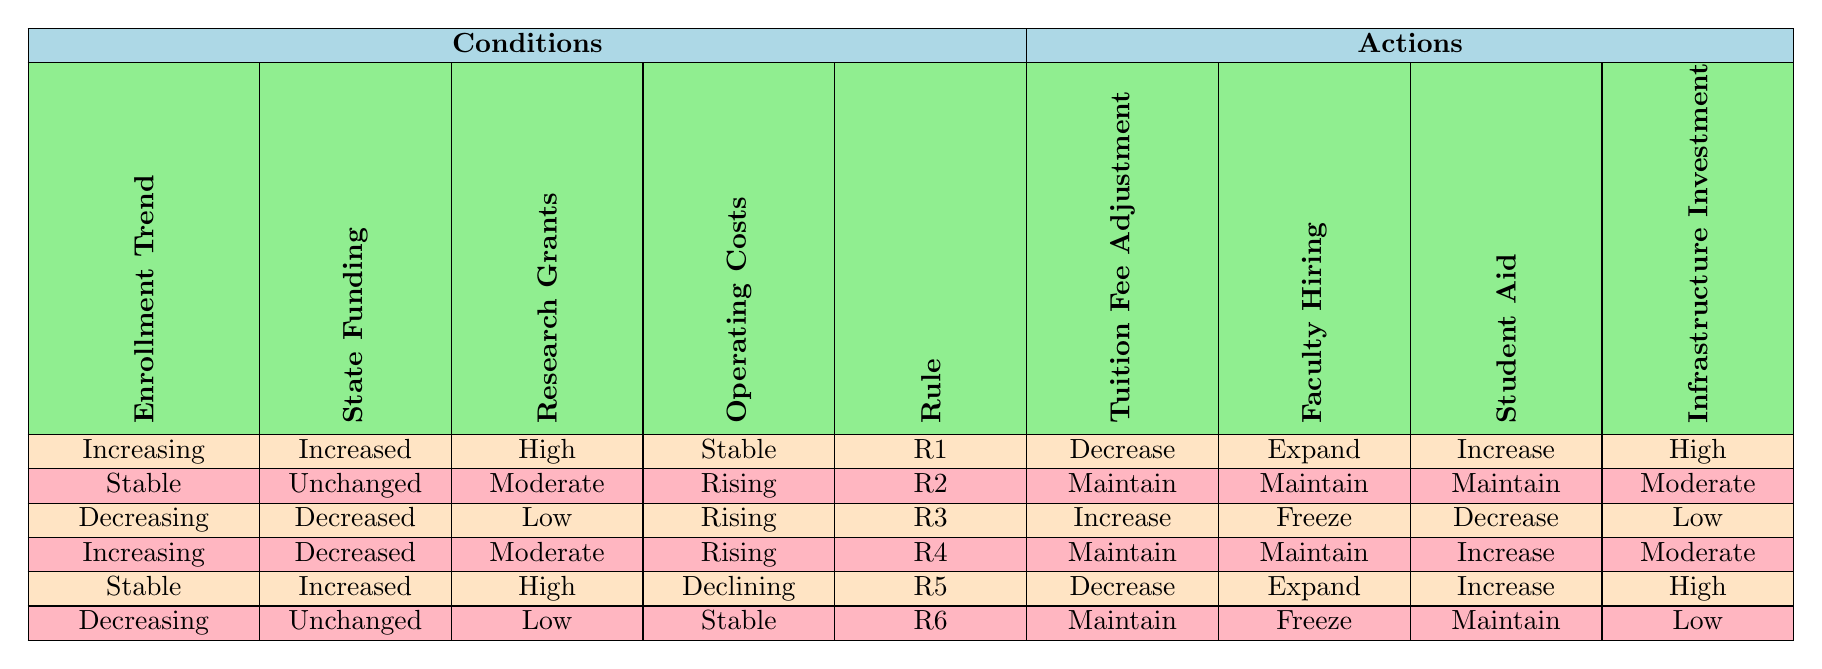What is the recommended action for tuition fee adjustment when enrollment is increasing, state funding has increased, research grants are high, and operating costs are stable? According to Rule R1 in the table, when all these conditions are met, the recommended action for tuition fee adjustment is to decrease.
Answer: Decrease What actions should be taken regarding faculty hiring and student aid when enrollment is stable, state funding is unchanged, research grants are moderate, and operating costs are rising? Referring to Rule R2, the actions recommended are to maintain both faculty hiring and student aid.
Answer: Maintain Is it true that an increase in tuition fees is suggested when enrollment is decreasing and research grants are low? By checking the rules, when enrollment is decreasing and research grants are low (as per Rule R3), the suggested action is to increase tuition fees. Therefore, the statement is true.
Answer: True What is the action for infrastructure investment if state funding is increased, enrollment trend is stable, research grants are high, and operating costs are declining? Looking at Rule R5, under these conditions of stable enrollment and increased funding with high research grants and declining costs, the action is to make a high investment in infrastructure.
Answer: High Which conditions lead to maintaining student aid when the enrollment trend is decreasing and state funding is unchanged? According to Rule R6, when enrollment is decreasing and state funding is unchanged, the actions specified are to freeze faculty hiring, maintain student aid, and keep infrastructure investment low. Hence, maintaining student aid is one of the actions.
Answer: Maintained What is the average number of actions suggested for changes in faculty hiring across all rules? There are 6 rules in the table: "Expand", "Maintain", "Freeze", "Maintain", "Expand", and "Freeze". Summing these up gives us the distinct actions: 2 "Expand", 3 "Maintain", and 2 "Freeze", thus the average could be calculated as: (2 + 3 + 2) / 6 = 0.833, or considering distinct values, that is around 1.33 unique actions per rule.
Answer: 1.33 If the research grants are low and the enrollment trend is stable, what should happen to faculty hiring? From Rule R2, with stable enrollment and low research grants, it suggests to maintain faculty hiring. Therefore, under these conditions, the faculty hiring should not change.
Answer: Maintain What combination of conditions results in freezing faculty hiring? The table shows that faculty hiring is frozen in two scenarios: Rule R3 (decreasing enrollment and low research grants with rising costs) and Rule R6 (decreasing enrollment and unchanged state funding). Therefore, these combinations lead to freezing faculty hiring.
Answer: Decreasing enrollment with low grants or unchanged funding 